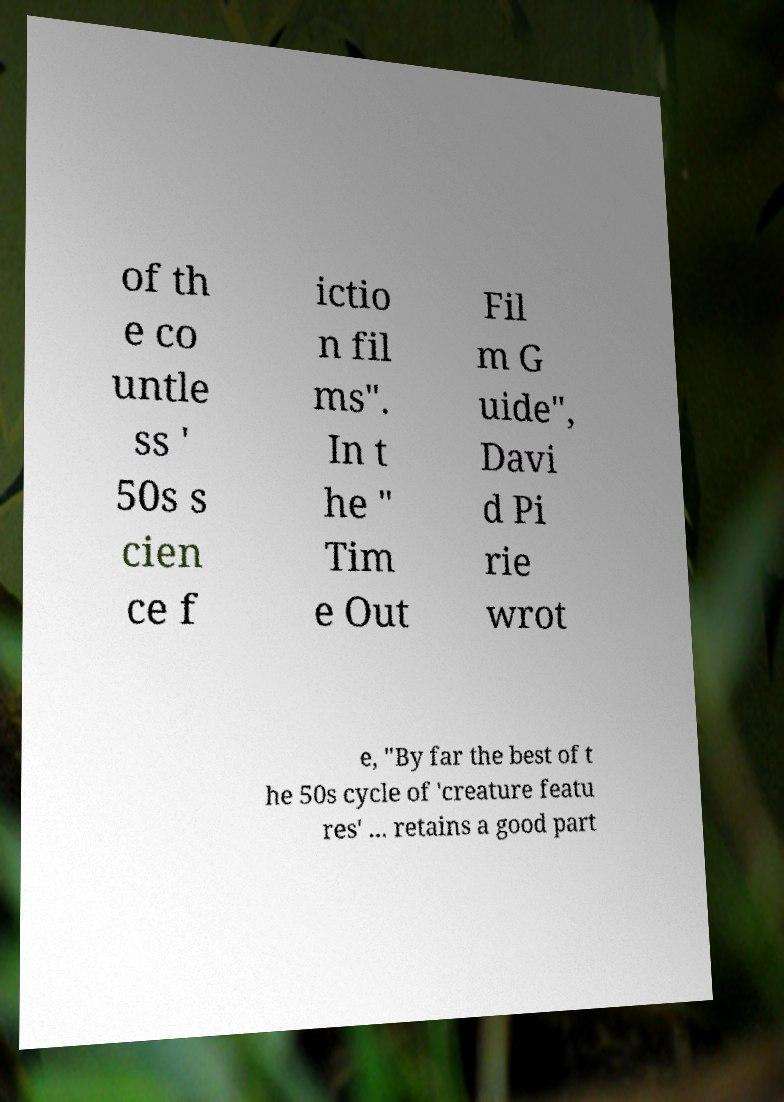For documentation purposes, I need the text within this image transcribed. Could you provide that? of th e co untle ss ' 50s s cien ce f ictio n fil ms". In t he " Tim e Out Fil m G uide", Davi d Pi rie wrot e, "By far the best of t he 50s cycle of 'creature featu res' ... retains a good part 